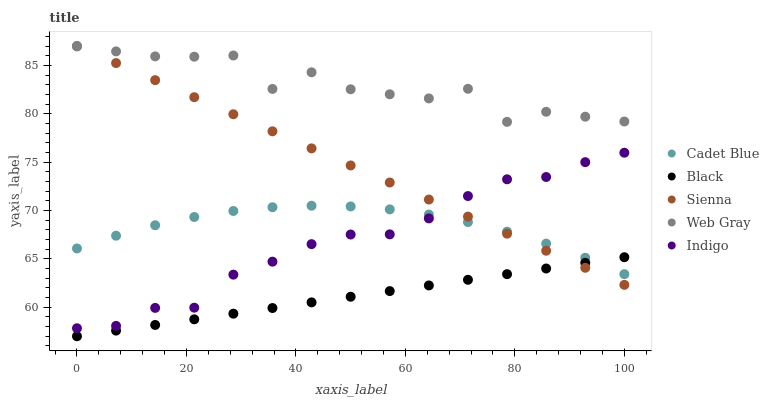Does Black have the minimum area under the curve?
Answer yes or no. Yes. Does Web Gray have the maximum area under the curve?
Answer yes or no. Yes. Does Indigo have the minimum area under the curve?
Answer yes or no. No. Does Indigo have the maximum area under the curve?
Answer yes or no. No. Is Black the smoothest?
Answer yes or no. Yes. Is Web Gray the roughest?
Answer yes or no. Yes. Is Indigo the smoothest?
Answer yes or no. No. Is Indigo the roughest?
Answer yes or no. No. Does Black have the lowest value?
Answer yes or no. Yes. Does Indigo have the lowest value?
Answer yes or no. No. Does Sienna have the highest value?
Answer yes or no. Yes. Does Indigo have the highest value?
Answer yes or no. No. Is Black less than Web Gray?
Answer yes or no. Yes. Is Web Gray greater than Indigo?
Answer yes or no. Yes. Does Cadet Blue intersect Indigo?
Answer yes or no. Yes. Is Cadet Blue less than Indigo?
Answer yes or no. No. Is Cadet Blue greater than Indigo?
Answer yes or no. No. Does Black intersect Web Gray?
Answer yes or no. No. 